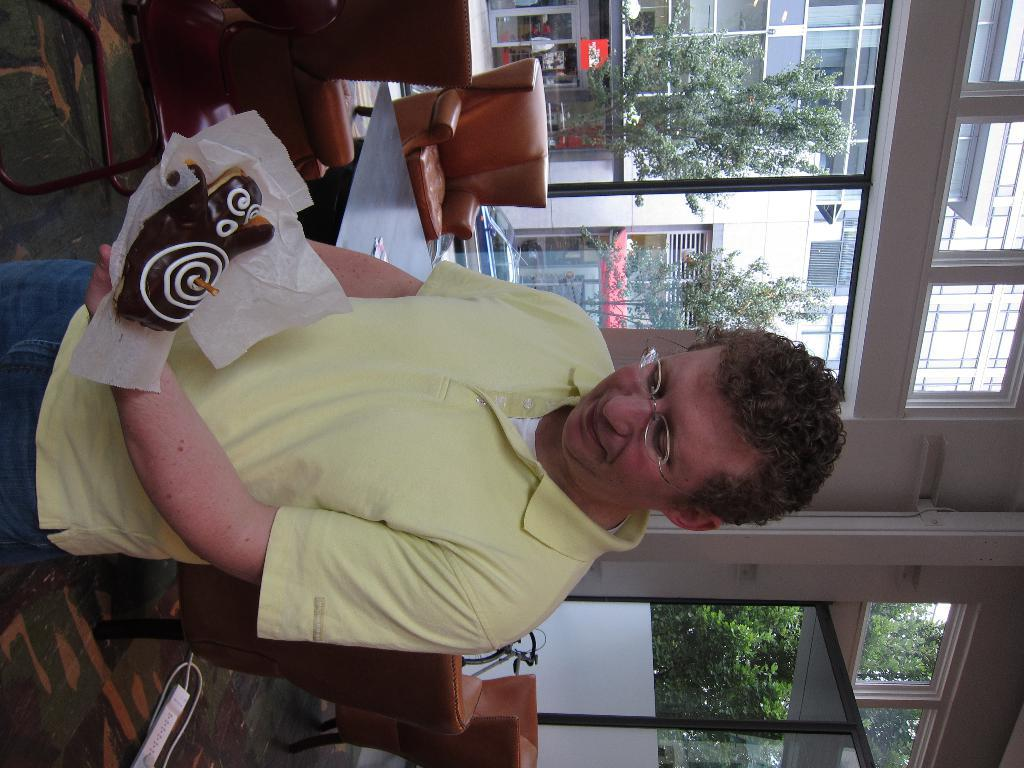What is the main subject of the image? There is a person in the image. What is the person holding in the image? The person is holding a food item. What can be seen in the background of the image? There are trees, buildings, chairs, a table, and windows in the background of the image. What type of coat is the person wearing in the image? There is no coat visible in the image; the person is not wearing one. Can you tell me where the nearest zoo is in relation to the image? There is no information about a zoo or its location in the image. 